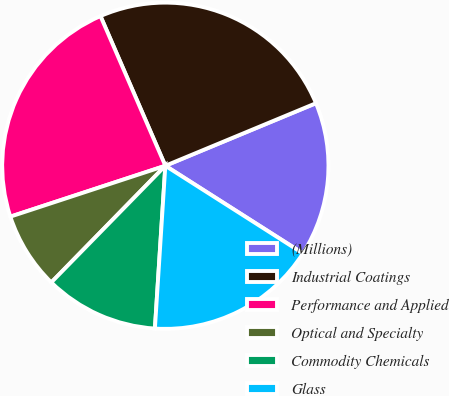<chart> <loc_0><loc_0><loc_500><loc_500><pie_chart><fcel>(Millions)<fcel>Industrial Coatings<fcel>Performance and Applied<fcel>Optical and Specialty<fcel>Commodity Chemicals<fcel>Glass<nl><fcel>15.29%<fcel>25.24%<fcel>23.54%<fcel>7.63%<fcel>11.3%<fcel>16.99%<nl></chart> 